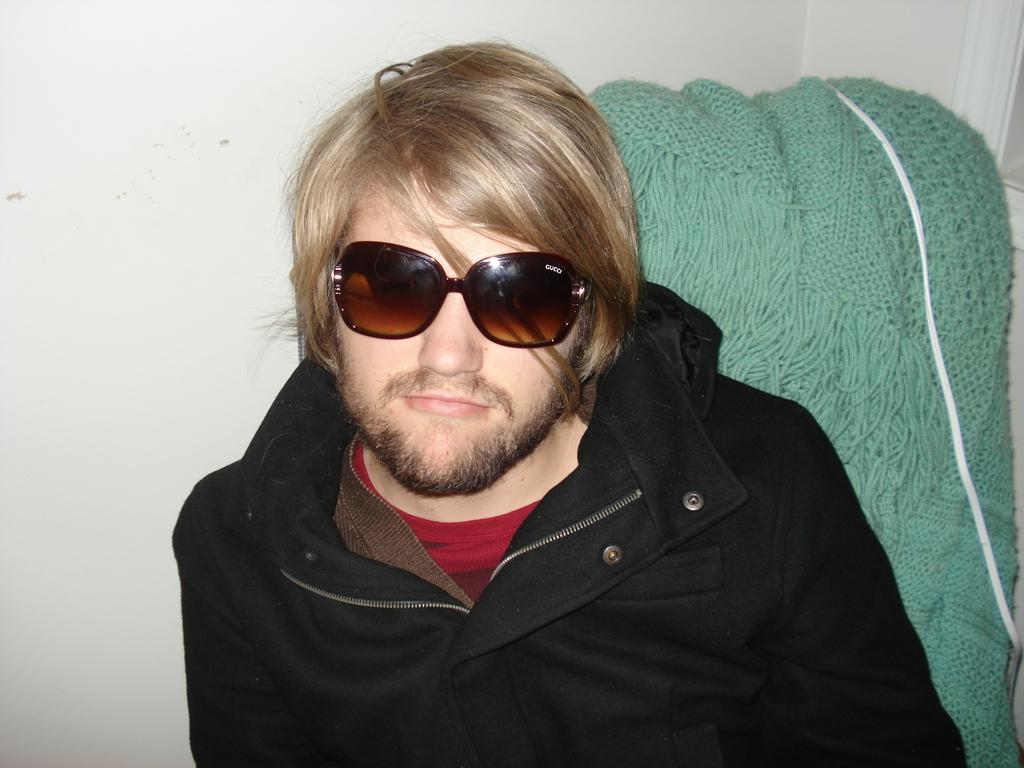What can be seen in the image? There is a person in the image. What is the person wearing? The person is wearing goggles and a jacket. What is visible in the background of the image? There is a wall, a wooden cloth, and a wire in the background of the image. What month is it in the image? The month cannot be determined from the image, as there is no information about the time of year or date. 